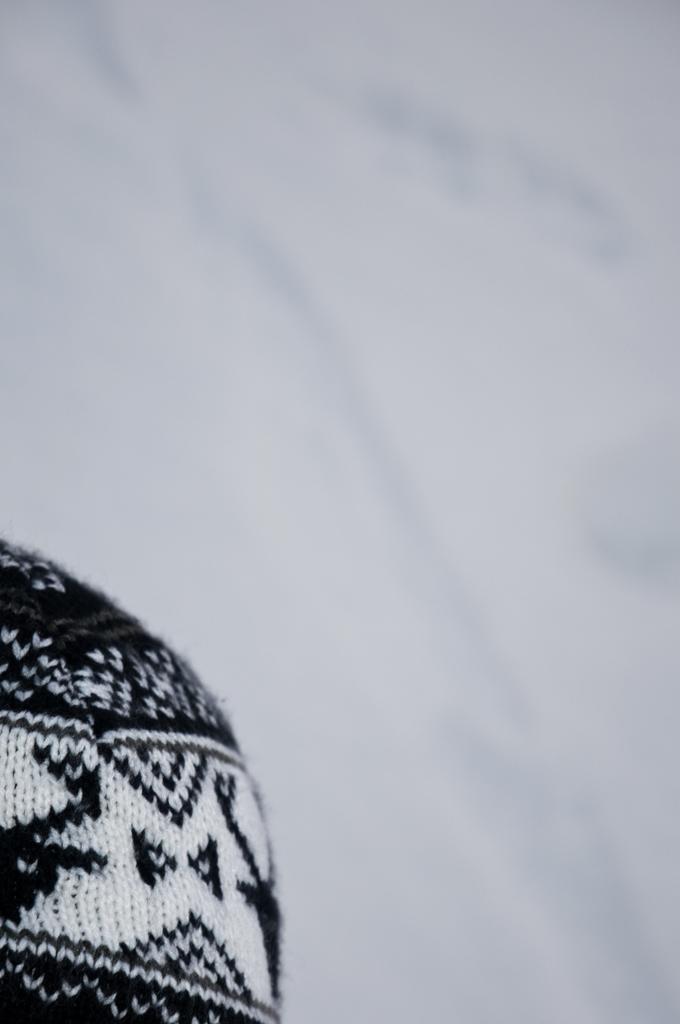Describe this image in one or two sentences. Left side bottom, we can see a woolen cloth. Background there is a blur view. Here we can see white color. 